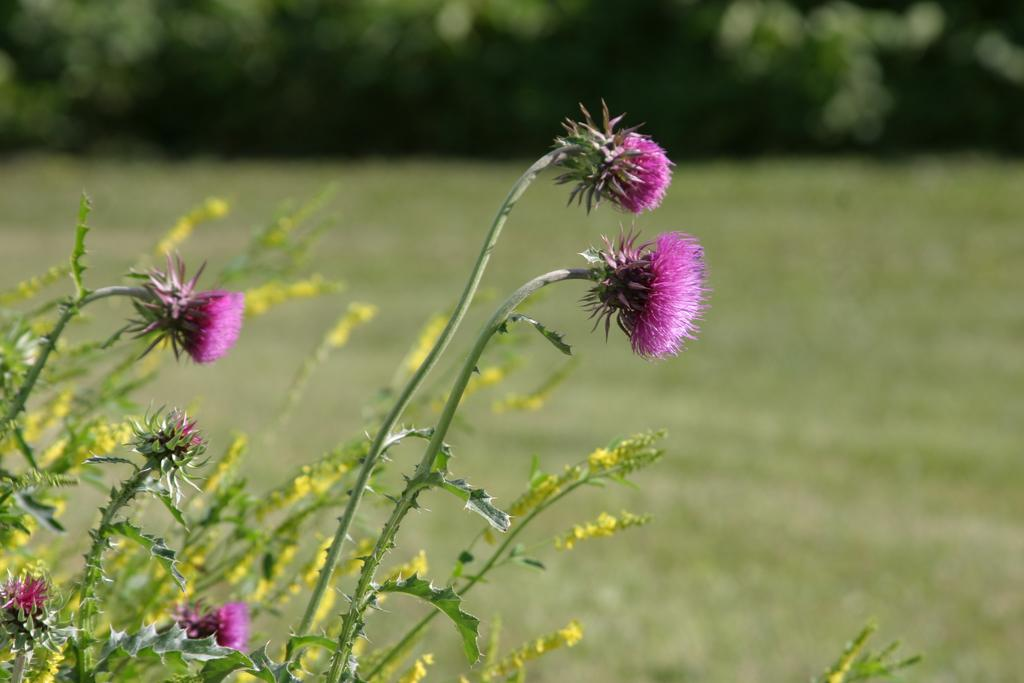What type of flowers can be seen in the image? There are purple color flowers in the image. What do the flowers belong to? The flowers belong to a plant. How would you describe the background of the image? The background of the image is blurred. What type of vegetation can be seen in the background? There is grass and trees visible in the background. How does the plant express regret in the image? There is no indication in the image that the plant or flowers are expressing regret, as plants do not have emotions or the ability to express regret. 